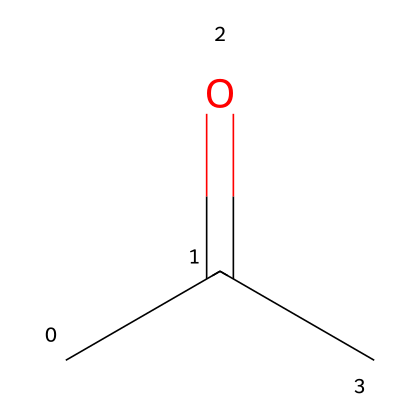What is the name of this chemical? The SMILES representation "CC(=O)C" corresponds to a ketone, specifically one with a three-carbon chain. The common name for this structure is acetone.
Answer: acetone How many carbon atoms are in this molecule? The SMILES shows "CC(=O)C," indicating three 'C' letters, which means there are three carbon atoms in this molecule.
Answer: three What type of functional group is present in acetone? The "C(=O)" notation in the SMILES indicates a carbonyl group (C=O), which is characteristic of ketones. Therefore, the functional group present in acetone is a carbonyl group.
Answer: carbonyl What is the total number of hydrogen atoms in acetone? Each carbon in acetone typically forms four bonds: the first carbon is connected to three hydrogens, the second carbon to one hydrogen and a carbonyl group, and the third carbon to three hydrogens. This totals to 6 hydrogen atoms.
Answer: six How many degrees of unsaturation does acetone have? The formula for calculating degrees of unsaturation is (2C + 2 - H)/2. Using 3 carbon atoms and 6 hydrogen atoms, we find (2*3 + 2 - 6)/2 = 1. This indicates 1 degree of unsaturation due to the carbonyl group.
Answer: one Is acetone a polar or non-polar solvent? Acetone has a polar carbonyl group, which leads to its overall polarity in the molecule compared to the non-polar hydrocarbon chain. Thus, acetone is classified as a polar solvent.
Answer: polar 